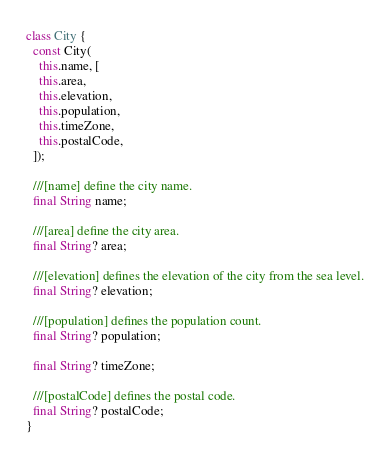<code> <loc_0><loc_0><loc_500><loc_500><_Dart_>class City {
  const City(
    this.name, [
    this.area,
    this.elevation,
    this.population,
    this.timeZone,
    this.postalCode,
  ]);

  ///[name] define the city name.
  final String name;

  ///[area] define the city area.
  final String? area;

  ///[elevation] defines the elevation of the city from the sea level.
  final String? elevation;

  ///[population] defines the population count.
  final String? population;

  final String? timeZone;

  ///[postalCode] defines the postal code.
  final String? postalCode;
}
</code> 